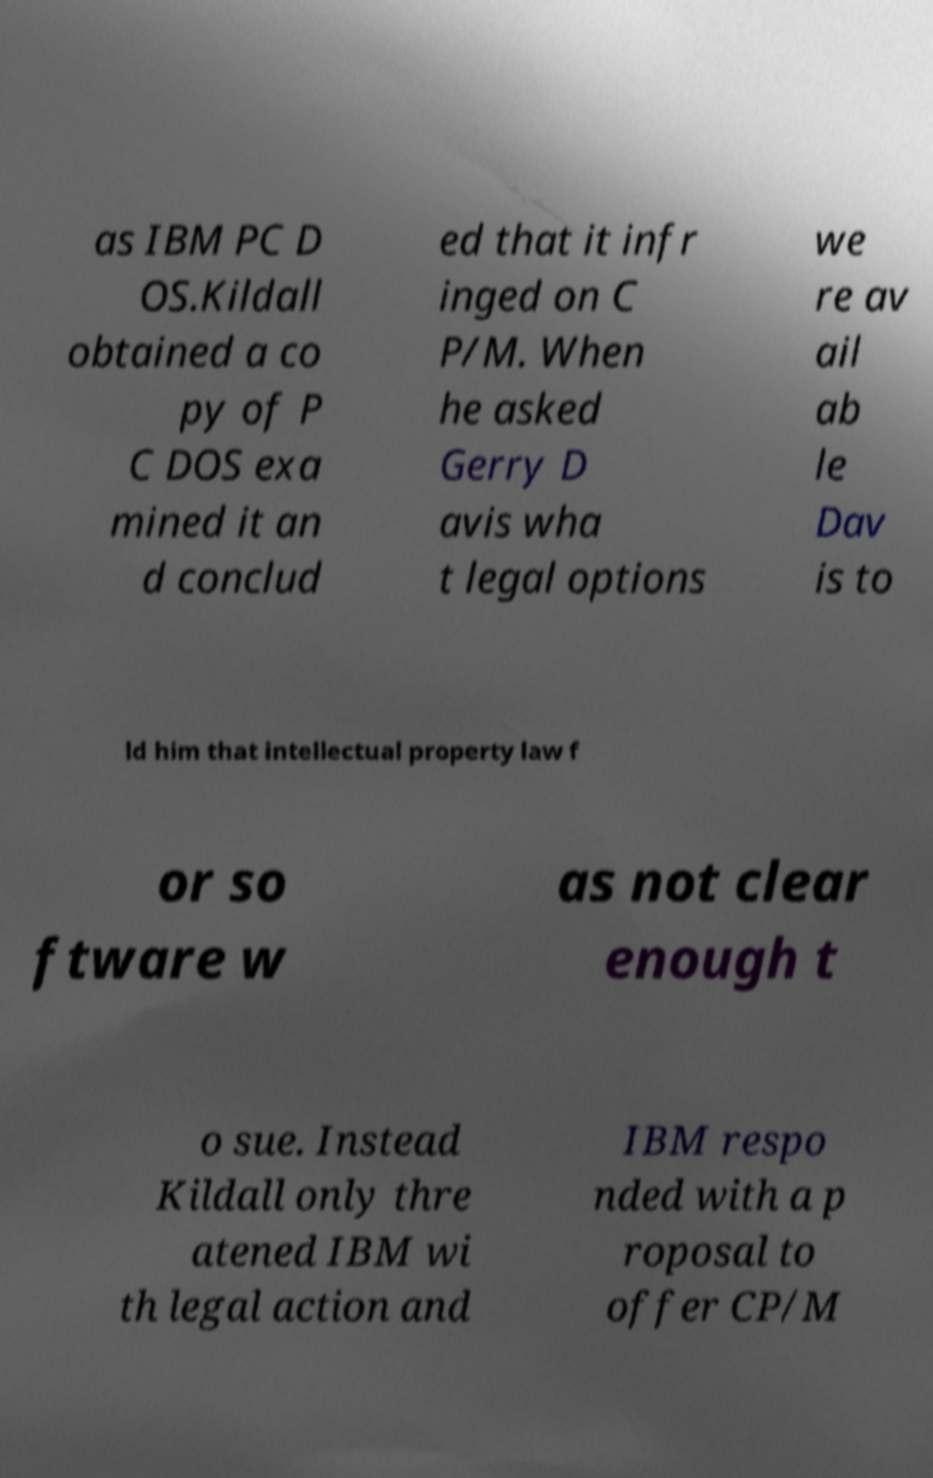Please identify and transcribe the text found in this image. as IBM PC D OS.Kildall obtained a co py of P C DOS exa mined it an d conclud ed that it infr inged on C P/M. When he asked Gerry D avis wha t legal options we re av ail ab le Dav is to ld him that intellectual property law f or so ftware w as not clear enough t o sue. Instead Kildall only thre atened IBM wi th legal action and IBM respo nded with a p roposal to offer CP/M 